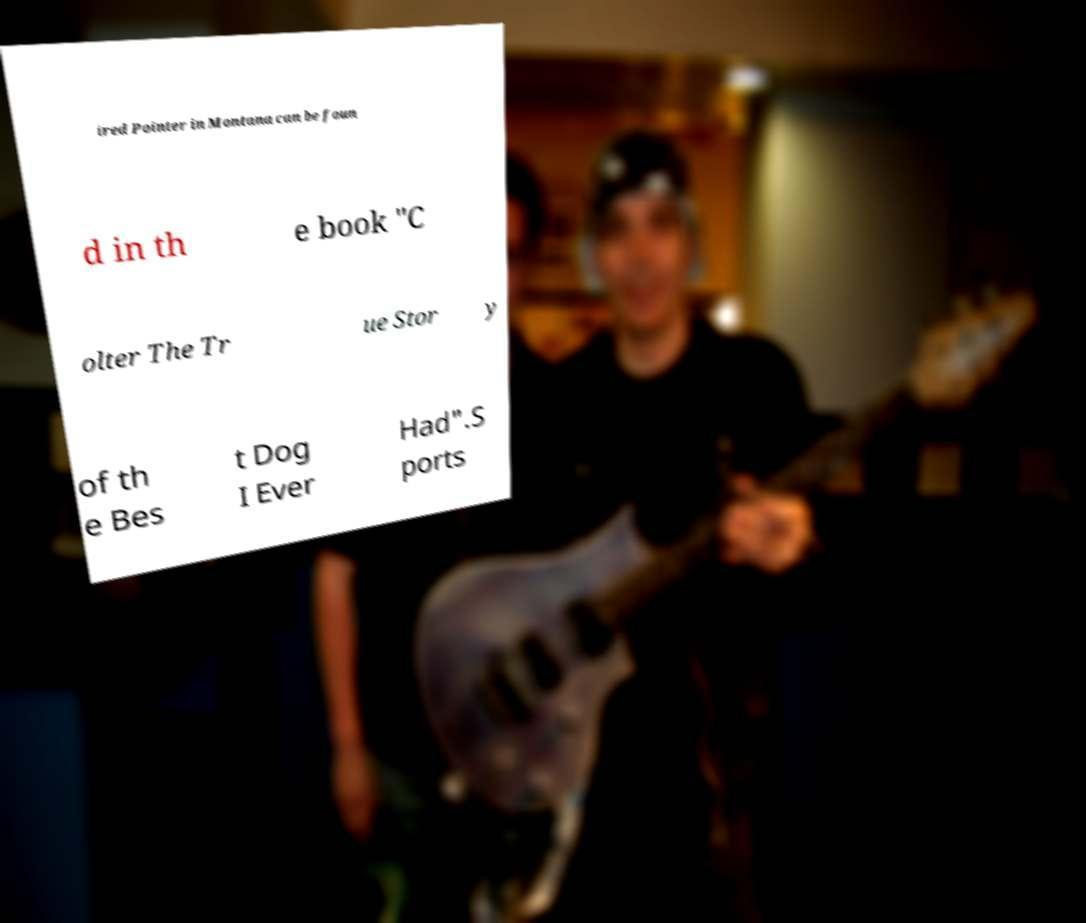Please read and relay the text visible in this image. What does it say? ired Pointer in Montana can be foun d in th e book "C olter The Tr ue Stor y of th e Bes t Dog I Ever Had".S ports 